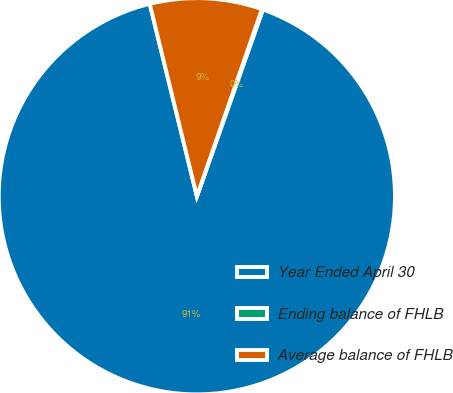Convert chart to OTSL. <chart><loc_0><loc_0><loc_500><loc_500><pie_chart><fcel>Year Ended April 30<fcel>Ending balance of FHLB<fcel>Average balance of FHLB<nl><fcel>90.76%<fcel>0.09%<fcel>9.15%<nl></chart> 